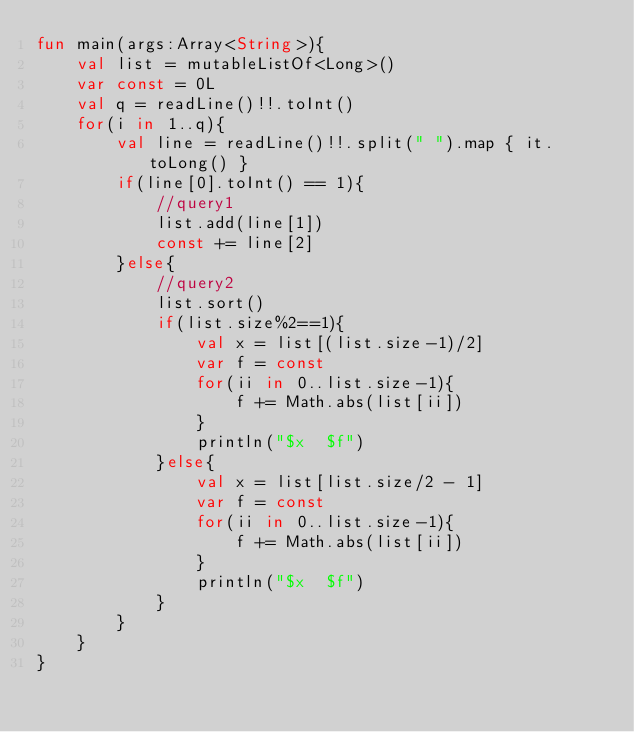Convert code to text. <code><loc_0><loc_0><loc_500><loc_500><_Kotlin_>fun main(args:Array<String>){
    val list = mutableListOf<Long>()
    var const = 0L
    val q = readLine()!!.toInt()
    for(i in 1..q){
        val line = readLine()!!.split(" ").map { it.toLong() }
        if(line[0].toInt() == 1){
            //query1
            list.add(line[1])
            const += line[2]
        }else{
            //query2
            list.sort()
            if(list.size%2==1){
                val x = list[(list.size-1)/2]
                var f = const
                for(ii in 0..list.size-1){
                    f += Math.abs(list[ii])
                }
                println("$x  $f")
            }else{
                val x = list[list.size/2 - 1]
                var f = const
                for(ii in 0..list.size-1){
                    f += Math.abs(list[ii])
                }
                println("$x  $f")
            }
        }
    }
}</code> 